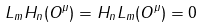<formula> <loc_0><loc_0><loc_500><loc_500>L _ { m } H _ { n } ( O ^ { \mu } ) = H _ { n } L _ { m } ( O ^ { \mu } ) = 0</formula> 